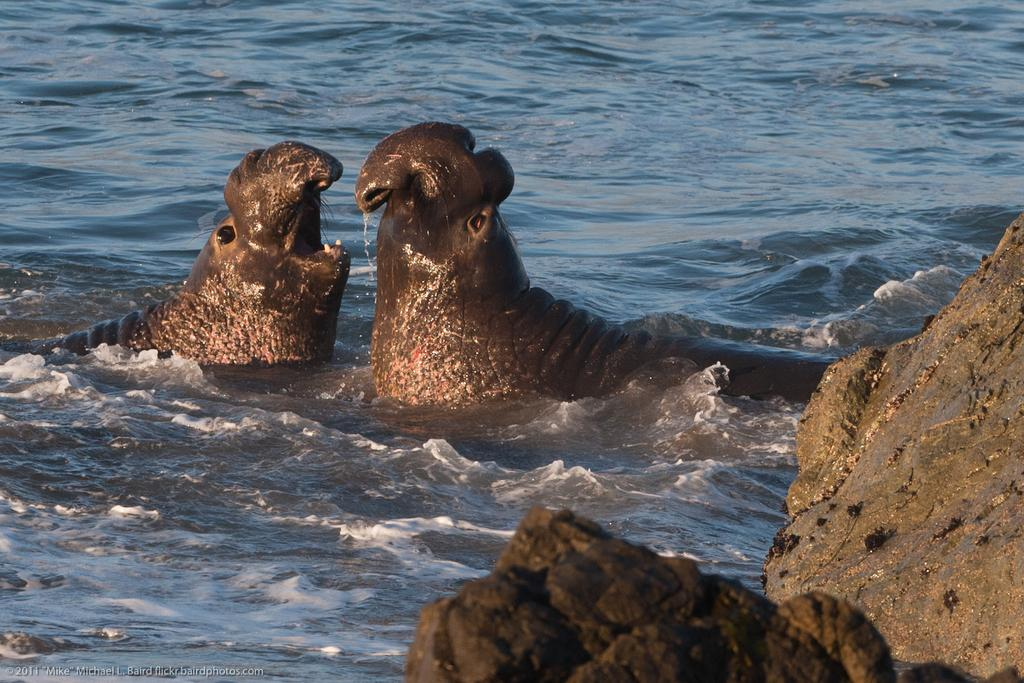How many animals are present in the image? There are two animals in the image. What color are the animals? The animals are in brown color. Where are the animals located in the image? The animals are in the water. What color is the water in the image? The water is in blue color. Who is the owner of the twig in the image? There is no twig present in the image. What type of payment is required to enter the water in the image? There is no indication of any payment required to enter the water in the image. 